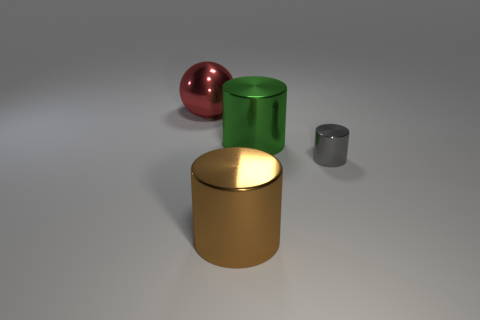Is there a cylinder that has the same size as the green metal thing?
Your answer should be very brief. Yes. Is the size of the object that is left of the large brown object the same as the thing right of the green thing?
Your answer should be very brief. No. How many objects are large brown cubes or cylinders that are left of the green metal cylinder?
Provide a succinct answer. 1. Is there a small green matte thing of the same shape as the gray object?
Provide a succinct answer. No. What is the size of the shiny cylinder that is to the left of the big metallic cylinder behind the brown metal thing?
Your response must be concise. Large. Is the small cylinder the same color as the big ball?
Your answer should be compact. No. How many matte things are small things or green objects?
Provide a short and direct response. 0. What number of small cyan metal things are there?
Offer a very short reply. 0. There is a tiny object that is the same shape as the large green object; what color is it?
Provide a short and direct response. Gray. What material is the object to the right of the big cylinder that is behind the brown metallic thing?
Make the answer very short. Metal. 